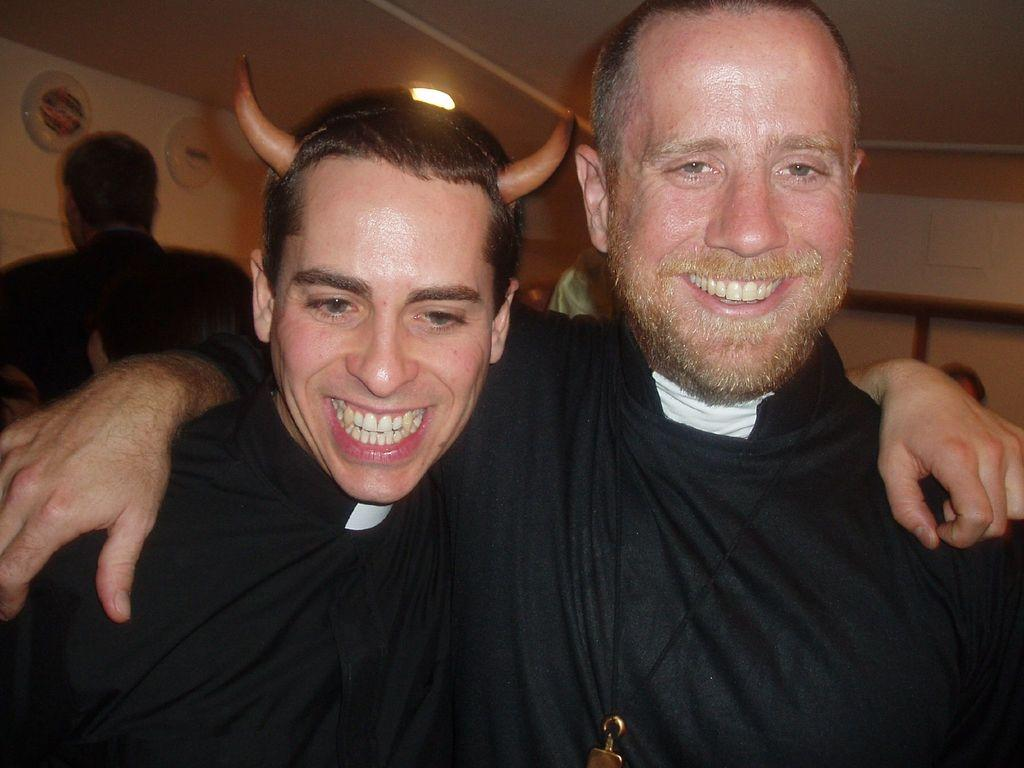How many people are present in the image? There are three persons in the image. What can be seen in the background of the image? There is a wall and a light in the background of the image. Are there any other people visible in the background? Yes, there are two additional persons in the background of the image. What type of location might the image have been taken in? The image may have been taken in a hall. What decision did the person in the center make before the image was taken? There is no information available in the image to determine any decisions made by the people before the image was taken. 